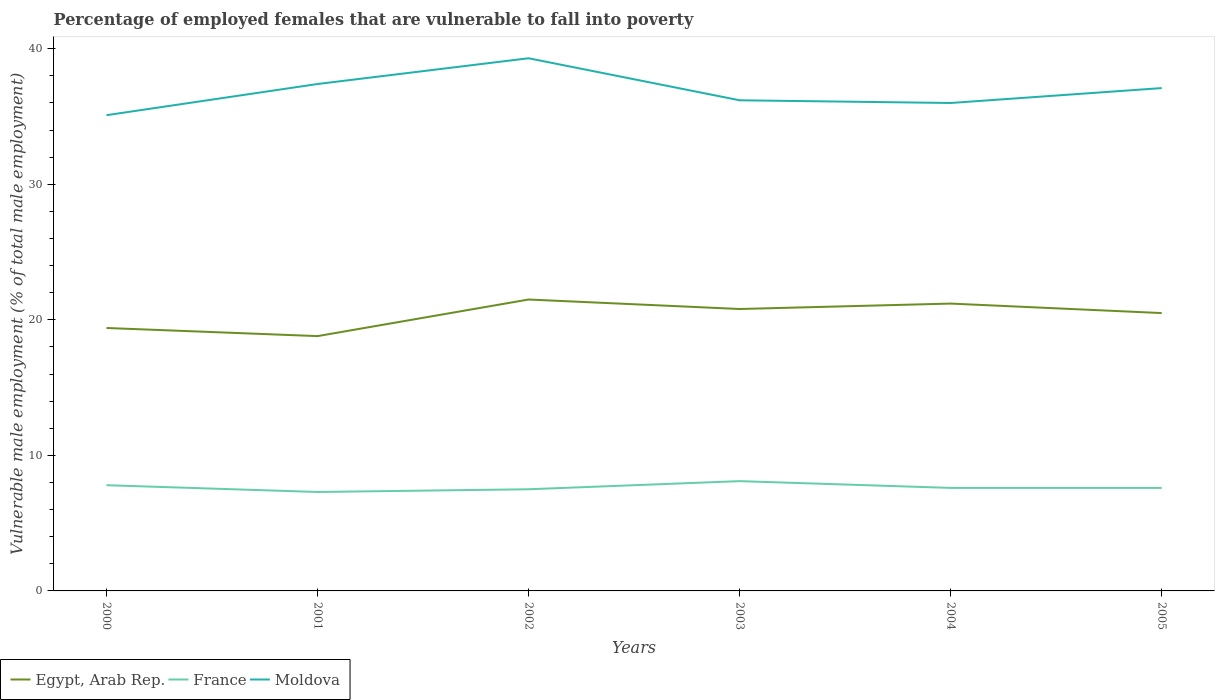Across all years, what is the maximum percentage of employed females who are vulnerable to fall into poverty in Egypt, Arab Rep.?
Keep it short and to the point. 18.8. In which year was the percentage of employed females who are vulnerable to fall into poverty in Egypt, Arab Rep. maximum?
Offer a terse response. 2001. What is the total percentage of employed females who are vulnerable to fall into poverty in France in the graph?
Your answer should be very brief. 0.5. What is the difference between the highest and the second highest percentage of employed females who are vulnerable to fall into poverty in Moldova?
Offer a very short reply. 4.2. How many years are there in the graph?
Provide a short and direct response. 6. What is the difference between two consecutive major ticks on the Y-axis?
Give a very brief answer. 10. Are the values on the major ticks of Y-axis written in scientific E-notation?
Give a very brief answer. No. Does the graph contain any zero values?
Offer a very short reply. No. Where does the legend appear in the graph?
Keep it short and to the point. Bottom left. How many legend labels are there?
Offer a very short reply. 3. What is the title of the graph?
Keep it short and to the point. Percentage of employed females that are vulnerable to fall into poverty. What is the label or title of the Y-axis?
Make the answer very short. Vulnerable male employment (% of total male employment). What is the Vulnerable male employment (% of total male employment) in Egypt, Arab Rep. in 2000?
Offer a terse response. 19.4. What is the Vulnerable male employment (% of total male employment) in France in 2000?
Offer a terse response. 7.8. What is the Vulnerable male employment (% of total male employment) of Moldova in 2000?
Keep it short and to the point. 35.1. What is the Vulnerable male employment (% of total male employment) of Egypt, Arab Rep. in 2001?
Ensure brevity in your answer.  18.8. What is the Vulnerable male employment (% of total male employment) in France in 2001?
Your response must be concise. 7.3. What is the Vulnerable male employment (% of total male employment) in Moldova in 2001?
Provide a short and direct response. 37.4. What is the Vulnerable male employment (% of total male employment) in Moldova in 2002?
Your answer should be compact. 39.3. What is the Vulnerable male employment (% of total male employment) of Egypt, Arab Rep. in 2003?
Your answer should be very brief. 20.8. What is the Vulnerable male employment (% of total male employment) of France in 2003?
Offer a terse response. 8.1. What is the Vulnerable male employment (% of total male employment) of Moldova in 2003?
Provide a short and direct response. 36.2. What is the Vulnerable male employment (% of total male employment) in Egypt, Arab Rep. in 2004?
Your answer should be very brief. 21.2. What is the Vulnerable male employment (% of total male employment) in France in 2004?
Your response must be concise. 7.6. What is the Vulnerable male employment (% of total male employment) of Moldova in 2004?
Provide a succinct answer. 36. What is the Vulnerable male employment (% of total male employment) of Egypt, Arab Rep. in 2005?
Give a very brief answer. 20.5. What is the Vulnerable male employment (% of total male employment) in France in 2005?
Provide a succinct answer. 7.6. What is the Vulnerable male employment (% of total male employment) of Moldova in 2005?
Your answer should be very brief. 37.1. Across all years, what is the maximum Vulnerable male employment (% of total male employment) of France?
Your answer should be very brief. 8.1. Across all years, what is the maximum Vulnerable male employment (% of total male employment) of Moldova?
Keep it short and to the point. 39.3. Across all years, what is the minimum Vulnerable male employment (% of total male employment) of Egypt, Arab Rep.?
Keep it short and to the point. 18.8. Across all years, what is the minimum Vulnerable male employment (% of total male employment) of France?
Offer a terse response. 7.3. Across all years, what is the minimum Vulnerable male employment (% of total male employment) in Moldova?
Provide a succinct answer. 35.1. What is the total Vulnerable male employment (% of total male employment) in Egypt, Arab Rep. in the graph?
Give a very brief answer. 122.2. What is the total Vulnerable male employment (% of total male employment) of France in the graph?
Offer a terse response. 45.9. What is the total Vulnerable male employment (% of total male employment) of Moldova in the graph?
Make the answer very short. 221.1. What is the difference between the Vulnerable male employment (% of total male employment) of Egypt, Arab Rep. in 2000 and that in 2001?
Your answer should be very brief. 0.6. What is the difference between the Vulnerable male employment (% of total male employment) in Moldova in 2000 and that in 2001?
Make the answer very short. -2.3. What is the difference between the Vulnerable male employment (% of total male employment) in France in 2000 and that in 2002?
Make the answer very short. 0.3. What is the difference between the Vulnerable male employment (% of total male employment) of Moldova in 2000 and that in 2002?
Provide a succinct answer. -4.2. What is the difference between the Vulnerable male employment (% of total male employment) in Egypt, Arab Rep. in 2000 and that in 2003?
Your response must be concise. -1.4. What is the difference between the Vulnerable male employment (% of total male employment) in France in 2000 and that in 2003?
Give a very brief answer. -0.3. What is the difference between the Vulnerable male employment (% of total male employment) in France in 2000 and that in 2004?
Your answer should be compact. 0.2. What is the difference between the Vulnerable male employment (% of total male employment) of Egypt, Arab Rep. in 2000 and that in 2005?
Provide a succinct answer. -1.1. What is the difference between the Vulnerable male employment (% of total male employment) of Moldova in 2000 and that in 2005?
Provide a succinct answer. -2. What is the difference between the Vulnerable male employment (% of total male employment) of Egypt, Arab Rep. in 2001 and that in 2002?
Make the answer very short. -2.7. What is the difference between the Vulnerable male employment (% of total male employment) of Egypt, Arab Rep. in 2001 and that in 2003?
Make the answer very short. -2. What is the difference between the Vulnerable male employment (% of total male employment) of Moldova in 2001 and that in 2003?
Offer a terse response. 1.2. What is the difference between the Vulnerable male employment (% of total male employment) in Egypt, Arab Rep. in 2001 and that in 2004?
Give a very brief answer. -2.4. What is the difference between the Vulnerable male employment (% of total male employment) of France in 2001 and that in 2004?
Ensure brevity in your answer.  -0.3. What is the difference between the Vulnerable male employment (% of total male employment) of Moldova in 2001 and that in 2004?
Make the answer very short. 1.4. What is the difference between the Vulnerable male employment (% of total male employment) in France in 2002 and that in 2003?
Make the answer very short. -0.6. What is the difference between the Vulnerable male employment (% of total male employment) of Moldova in 2002 and that in 2003?
Ensure brevity in your answer.  3.1. What is the difference between the Vulnerable male employment (% of total male employment) of Egypt, Arab Rep. in 2002 and that in 2004?
Provide a succinct answer. 0.3. What is the difference between the Vulnerable male employment (% of total male employment) in France in 2002 and that in 2004?
Your response must be concise. -0.1. What is the difference between the Vulnerable male employment (% of total male employment) in Egypt, Arab Rep. in 2002 and that in 2005?
Make the answer very short. 1. What is the difference between the Vulnerable male employment (% of total male employment) of France in 2002 and that in 2005?
Provide a short and direct response. -0.1. What is the difference between the Vulnerable male employment (% of total male employment) of Egypt, Arab Rep. in 2003 and that in 2004?
Give a very brief answer. -0.4. What is the difference between the Vulnerable male employment (% of total male employment) in Moldova in 2003 and that in 2004?
Provide a succinct answer. 0.2. What is the difference between the Vulnerable male employment (% of total male employment) of Egypt, Arab Rep. in 2003 and that in 2005?
Give a very brief answer. 0.3. What is the difference between the Vulnerable male employment (% of total male employment) in Moldova in 2003 and that in 2005?
Provide a short and direct response. -0.9. What is the difference between the Vulnerable male employment (% of total male employment) of Egypt, Arab Rep. in 2004 and that in 2005?
Your response must be concise. 0.7. What is the difference between the Vulnerable male employment (% of total male employment) in France in 2004 and that in 2005?
Keep it short and to the point. 0. What is the difference between the Vulnerable male employment (% of total male employment) in Moldova in 2004 and that in 2005?
Offer a very short reply. -1.1. What is the difference between the Vulnerable male employment (% of total male employment) of Egypt, Arab Rep. in 2000 and the Vulnerable male employment (% of total male employment) of Moldova in 2001?
Your answer should be compact. -18. What is the difference between the Vulnerable male employment (% of total male employment) in France in 2000 and the Vulnerable male employment (% of total male employment) in Moldova in 2001?
Provide a short and direct response. -29.6. What is the difference between the Vulnerable male employment (% of total male employment) of Egypt, Arab Rep. in 2000 and the Vulnerable male employment (% of total male employment) of France in 2002?
Keep it short and to the point. 11.9. What is the difference between the Vulnerable male employment (% of total male employment) in Egypt, Arab Rep. in 2000 and the Vulnerable male employment (% of total male employment) in Moldova in 2002?
Your response must be concise. -19.9. What is the difference between the Vulnerable male employment (% of total male employment) of France in 2000 and the Vulnerable male employment (% of total male employment) of Moldova in 2002?
Offer a very short reply. -31.5. What is the difference between the Vulnerable male employment (% of total male employment) of Egypt, Arab Rep. in 2000 and the Vulnerable male employment (% of total male employment) of France in 2003?
Your answer should be very brief. 11.3. What is the difference between the Vulnerable male employment (% of total male employment) of Egypt, Arab Rep. in 2000 and the Vulnerable male employment (% of total male employment) of Moldova in 2003?
Give a very brief answer. -16.8. What is the difference between the Vulnerable male employment (% of total male employment) of France in 2000 and the Vulnerable male employment (% of total male employment) of Moldova in 2003?
Your answer should be compact. -28.4. What is the difference between the Vulnerable male employment (% of total male employment) in Egypt, Arab Rep. in 2000 and the Vulnerable male employment (% of total male employment) in Moldova in 2004?
Keep it short and to the point. -16.6. What is the difference between the Vulnerable male employment (% of total male employment) in France in 2000 and the Vulnerable male employment (% of total male employment) in Moldova in 2004?
Your answer should be compact. -28.2. What is the difference between the Vulnerable male employment (% of total male employment) of Egypt, Arab Rep. in 2000 and the Vulnerable male employment (% of total male employment) of France in 2005?
Your answer should be compact. 11.8. What is the difference between the Vulnerable male employment (% of total male employment) in Egypt, Arab Rep. in 2000 and the Vulnerable male employment (% of total male employment) in Moldova in 2005?
Your answer should be compact. -17.7. What is the difference between the Vulnerable male employment (% of total male employment) in France in 2000 and the Vulnerable male employment (% of total male employment) in Moldova in 2005?
Provide a short and direct response. -29.3. What is the difference between the Vulnerable male employment (% of total male employment) of Egypt, Arab Rep. in 2001 and the Vulnerable male employment (% of total male employment) of France in 2002?
Your answer should be compact. 11.3. What is the difference between the Vulnerable male employment (% of total male employment) in Egypt, Arab Rep. in 2001 and the Vulnerable male employment (% of total male employment) in Moldova in 2002?
Your answer should be compact. -20.5. What is the difference between the Vulnerable male employment (% of total male employment) in France in 2001 and the Vulnerable male employment (% of total male employment) in Moldova in 2002?
Make the answer very short. -32. What is the difference between the Vulnerable male employment (% of total male employment) in Egypt, Arab Rep. in 2001 and the Vulnerable male employment (% of total male employment) in France in 2003?
Your response must be concise. 10.7. What is the difference between the Vulnerable male employment (% of total male employment) of Egypt, Arab Rep. in 2001 and the Vulnerable male employment (% of total male employment) of Moldova in 2003?
Offer a terse response. -17.4. What is the difference between the Vulnerable male employment (% of total male employment) of France in 2001 and the Vulnerable male employment (% of total male employment) of Moldova in 2003?
Make the answer very short. -28.9. What is the difference between the Vulnerable male employment (% of total male employment) in Egypt, Arab Rep. in 2001 and the Vulnerable male employment (% of total male employment) in Moldova in 2004?
Your response must be concise. -17.2. What is the difference between the Vulnerable male employment (% of total male employment) in France in 2001 and the Vulnerable male employment (% of total male employment) in Moldova in 2004?
Give a very brief answer. -28.7. What is the difference between the Vulnerable male employment (% of total male employment) of Egypt, Arab Rep. in 2001 and the Vulnerable male employment (% of total male employment) of France in 2005?
Offer a very short reply. 11.2. What is the difference between the Vulnerable male employment (% of total male employment) of Egypt, Arab Rep. in 2001 and the Vulnerable male employment (% of total male employment) of Moldova in 2005?
Offer a terse response. -18.3. What is the difference between the Vulnerable male employment (% of total male employment) in France in 2001 and the Vulnerable male employment (% of total male employment) in Moldova in 2005?
Ensure brevity in your answer.  -29.8. What is the difference between the Vulnerable male employment (% of total male employment) in Egypt, Arab Rep. in 2002 and the Vulnerable male employment (% of total male employment) in France in 2003?
Your response must be concise. 13.4. What is the difference between the Vulnerable male employment (% of total male employment) of Egypt, Arab Rep. in 2002 and the Vulnerable male employment (% of total male employment) of Moldova in 2003?
Ensure brevity in your answer.  -14.7. What is the difference between the Vulnerable male employment (% of total male employment) of France in 2002 and the Vulnerable male employment (% of total male employment) of Moldova in 2003?
Give a very brief answer. -28.7. What is the difference between the Vulnerable male employment (% of total male employment) of Egypt, Arab Rep. in 2002 and the Vulnerable male employment (% of total male employment) of France in 2004?
Offer a terse response. 13.9. What is the difference between the Vulnerable male employment (% of total male employment) of Egypt, Arab Rep. in 2002 and the Vulnerable male employment (% of total male employment) of Moldova in 2004?
Provide a short and direct response. -14.5. What is the difference between the Vulnerable male employment (% of total male employment) of France in 2002 and the Vulnerable male employment (% of total male employment) of Moldova in 2004?
Provide a short and direct response. -28.5. What is the difference between the Vulnerable male employment (% of total male employment) of Egypt, Arab Rep. in 2002 and the Vulnerable male employment (% of total male employment) of France in 2005?
Offer a very short reply. 13.9. What is the difference between the Vulnerable male employment (% of total male employment) in Egypt, Arab Rep. in 2002 and the Vulnerable male employment (% of total male employment) in Moldova in 2005?
Provide a short and direct response. -15.6. What is the difference between the Vulnerable male employment (% of total male employment) in France in 2002 and the Vulnerable male employment (% of total male employment) in Moldova in 2005?
Keep it short and to the point. -29.6. What is the difference between the Vulnerable male employment (% of total male employment) of Egypt, Arab Rep. in 2003 and the Vulnerable male employment (% of total male employment) of Moldova in 2004?
Provide a short and direct response. -15.2. What is the difference between the Vulnerable male employment (% of total male employment) in France in 2003 and the Vulnerable male employment (% of total male employment) in Moldova in 2004?
Provide a short and direct response. -27.9. What is the difference between the Vulnerable male employment (% of total male employment) in Egypt, Arab Rep. in 2003 and the Vulnerable male employment (% of total male employment) in Moldova in 2005?
Ensure brevity in your answer.  -16.3. What is the difference between the Vulnerable male employment (% of total male employment) of Egypt, Arab Rep. in 2004 and the Vulnerable male employment (% of total male employment) of Moldova in 2005?
Make the answer very short. -15.9. What is the difference between the Vulnerable male employment (% of total male employment) in France in 2004 and the Vulnerable male employment (% of total male employment) in Moldova in 2005?
Offer a terse response. -29.5. What is the average Vulnerable male employment (% of total male employment) in Egypt, Arab Rep. per year?
Make the answer very short. 20.37. What is the average Vulnerable male employment (% of total male employment) of France per year?
Ensure brevity in your answer.  7.65. What is the average Vulnerable male employment (% of total male employment) of Moldova per year?
Offer a very short reply. 36.85. In the year 2000, what is the difference between the Vulnerable male employment (% of total male employment) in Egypt, Arab Rep. and Vulnerable male employment (% of total male employment) in France?
Make the answer very short. 11.6. In the year 2000, what is the difference between the Vulnerable male employment (% of total male employment) of Egypt, Arab Rep. and Vulnerable male employment (% of total male employment) of Moldova?
Keep it short and to the point. -15.7. In the year 2000, what is the difference between the Vulnerable male employment (% of total male employment) in France and Vulnerable male employment (% of total male employment) in Moldova?
Provide a short and direct response. -27.3. In the year 2001, what is the difference between the Vulnerable male employment (% of total male employment) in Egypt, Arab Rep. and Vulnerable male employment (% of total male employment) in France?
Provide a succinct answer. 11.5. In the year 2001, what is the difference between the Vulnerable male employment (% of total male employment) in Egypt, Arab Rep. and Vulnerable male employment (% of total male employment) in Moldova?
Ensure brevity in your answer.  -18.6. In the year 2001, what is the difference between the Vulnerable male employment (% of total male employment) of France and Vulnerable male employment (% of total male employment) of Moldova?
Provide a short and direct response. -30.1. In the year 2002, what is the difference between the Vulnerable male employment (% of total male employment) of Egypt, Arab Rep. and Vulnerable male employment (% of total male employment) of France?
Give a very brief answer. 14. In the year 2002, what is the difference between the Vulnerable male employment (% of total male employment) in Egypt, Arab Rep. and Vulnerable male employment (% of total male employment) in Moldova?
Keep it short and to the point. -17.8. In the year 2002, what is the difference between the Vulnerable male employment (% of total male employment) in France and Vulnerable male employment (% of total male employment) in Moldova?
Ensure brevity in your answer.  -31.8. In the year 2003, what is the difference between the Vulnerable male employment (% of total male employment) in Egypt, Arab Rep. and Vulnerable male employment (% of total male employment) in France?
Your answer should be very brief. 12.7. In the year 2003, what is the difference between the Vulnerable male employment (% of total male employment) in Egypt, Arab Rep. and Vulnerable male employment (% of total male employment) in Moldova?
Offer a terse response. -15.4. In the year 2003, what is the difference between the Vulnerable male employment (% of total male employment) in France and Vulnerable male employment (% of total male employment) in Moldova?
Your answer should be compact. -28.1. In the year 2004, what is the difference between the Vulnerable male employment (% of total male employment) of Egypt, Arab Rep. and Vulnerable male employment (% of total male employment) of Moldova?
Ensure brevity in your answer.  -14.8. In the year 2004, what is the difference between the Vulnerable male employment (% of total male employment) in France and Vulnerable male employment (% of total male employment) in Moldova?
Make the answer very short. -28.4. In the year 2005, what is the difference between the Vulnerable male employment (% of total male employment) of Egypt, Arab Rep. and Vulnerable male employment (% of total male employment) of France?
Provide a short and direct response. 12.9. In the year 2005, what is the difference between the Vulnerable male employment (% of total male employment) in Egypt, Arab Rep. and Vulnerable male employment (% of total male employment) in Moldova?
Give a very brief answer. -16.6. In the year 2005, what is the difference between the Vulnerable male employment (% of total male employment) of France and Vulnerable male employment (% of total male employment) of Moldova?
Offer a very short reply. -29.5. What is the ratio of the Vulnerable male employment (% of total male employment) in Egypt, Arab Rep. in 2000 to that in 2001?
Your response must be concise. 1.03. What is the ratio of the Vulnerable male employment (% of total male employment) of France in 2000 to that in 2001?
Provide a succinct answer. 1.07. What is the ratio of the Vulnerable male employment (% of total male employment) in Moldova in 2000 to that in 2001?
Make the answer very short. 0.94. What is the ratio of the Vulnerable male employment (% of total male employment) in Egypt, Arab Rep. in 2000 to that in 2002?
Provide a short and direct response. 0.9. What is the ratio of the Vulnerable male employment (% of total male employment) in Moldova in 2000 to that in 2002?
Ensure brevity in your answer.  0.89. What is the ratio of the Vulnerable male employment (% of total male employment) in Egypt, Arab Rep. in 2000 to that in 2003?
Ensure brevity in your answer.  0.93. What is the ratio of the Vulnerable male employment (% of total male employment) of France in 2000 to that in 2003?
Give a very brief answer. 0.96. What is the ratio of the Vulnerable male employment (% of total male employment) of Moldova in 2000 to that in 2003?
Provide a succinct answer. 0.97. What is the ratio of the Vulnerable male employment (% of total male employment) of Egypt, Arab Rep. in 2000 to that in 2004?
Keep it short and to the point. 0.92. What is the ratio of the Vulnerable male employment (% of total male employment) of France in 2000 to that in 2004?
Offer a very short reply. 1.03. What is the ratio of the Vulnerable male employment (% of total male employment) of Egypt, Arab Rep. in 2000 to that in 2005?
Offer a terse response. 0.95. What is the ratio of the Vulnerable male employment (% of total male employment) in France in 2000 to that in 2005?
Your answer should be compact. 1.03. What is the ratio of the Vulnerable male employment (% of total male employment) in Moldova in 2000 to that in 2005?
Provide a short and direct response. 0.95. What is the ratio of the Vulnerable male employment (% of total male employment) of Egypt, Arab Rep. in 2001 to that in 2002?
Provide a succinct answer. 0.87. What is the ratio of the Vulnerable male employment (% of total male employment) in France in 2001 to that in 2002?
Your response must be concise. 0.97. What is the ratio of the Vulnerable male employment (% of total male employment) of Moldova in 2001 to that in 2002?
Offer a terse response. 0.95. What is the ratio of the Vulnerable male employment (% of total male employment) in Egypt, Arab Rep. in 2001 to that in 2003?
Ensure brevity in your answer.  0.9. What is the ratio of the Vulnerable male employment (% of total male employment) in France in 2001 to that in 2003?
Your answer should be compact. 0.9. What is the ratio of the Vulnerable male employment (% of total male employment) of Moldova in 2001 to that in 2003?
Your response must be concise. 1.03. What is the ratio of the Vulnerable male employment (% of total male employment) in Egypt, Arab Rep. in 2001 to that in 2004?
Your answer should be very brief. 0.89. What is the ratio of the Vulnerable male employment (% of total male employment) in France in 2001 to that in 2004?
Provide a succinct answer. 0.96. What is the ratio of the Vulnerable male employment (% of total male employment) in Moldova in 2001 to that in 2004?
Give a very brief answer. 1.04. What is the ratio of the Vulnerable male employment (% of total male employment) in Egypt, Arab Rep. in 2001 to that in 2005?
Your response must be concise. 0.92. What is the ratio of the Vulnerable male employment (% of total male employment) of France in 2001 to that in 2005?
Offer a very short reply. 0.96. What is the ratio of the Vulnerable male employment (% of total male employment) in Moldova in 2001 to that in 2005?
Your response must be concise. 1.01. What is the ratio of the Vulnerable male employment (% of total male employment) in Egypt, Arab Rep. in 2002 to that in 2003?
Ensure brevity in your answer.  1.03. What is the ratio of the Vulnerable male employment (% of total male employment) of France in 2002 to that in 2003?
Your response must be concise. 0.93. What is the ratio of the Vulnerable male employment (% of total male employment) in Moldova in 2002 to that in 2003?
Your response must be concise. 1.09. What is the ratio of the Vulnerable male employment (% of total male employment) in Egypt, Arab Rep. in 2002 to that in 2004?
Your response must be concise. 1.01. What is the ratio of the Vulnerable male employment (% of total male employment) of France in 2002 to that in 2004?
Give a very brief answer. 0.99. What is the ratio of the Vulnerable male employment (% of total male employment) in Moldova in 2002 to that in 2004?
Provide a succinct answer. 1.09. What is the ratio of the Vulnerable male employment (% of total male employment) of Egypt, Arab Rep. in 2002 to that in 2005?
Provide a short and direct response. 1.05. What is the ratio of the Vulnerable male employment (% of total male employment) in France in 2002 to that in 2005?
Your answer should be very brief. 0.99. What is the ratio of the Vulnerable male employment (% of total male employment) in Moldova in 2002 to that in 2005?
Make the answer very short. 1.06. What is the ratio of the Vulnerable male employment (% of total male employment) of Egypt, Arab Rep. in 2003 to that in 2004?
Provide a succinct answer. 0.98. What is the ratio of the Vulnerable male employment (% of total male employment) in France in 2003 to that in 2004?
Ensure brevity in your answer.  1.07. What is the ratio of the Vulnerable male employment (% of total male employment) of Moldova in 2003 to that in 2004?
Provide a succinct answer. 1.01. What is the ratio of the Vulnerable male employment (% of total male employment) of Egypt, Arab Rep. in 2003 to that in 2005?
Your answer should be compact. 1.01. What is the ratio of the Vulnerable male employment (% of total male employment) of France in 2003 to that in 2005?
Your answer should be very brief. 1.07. What is the ratio of the Vulnerable male employment (% of total male employment) in Moldova in 2003 to that in 2005?
Provide a short and direct response. 0.98. What is the ratio of the Vulnerable male employment (% of total male employment) of Egypt, Arab Rep. in 2004 to that in 2005?
Your answer should be very brief. 1.03. What is the ratio of the Vulnerable male employment (% of total male employment) of France in 2004 to that in 2005?
Provide a short and direct response. 1. What is the ratio of the Vulnerable male employment (% of total male employment) of Moldova in 2004 to that in 2005?
Your answer should be very brief. 0.97. What is the difference between the highest and the second highest Vulnerable male employment (% of total male employment) in Moldova?
Provide a succinct answer. 1.9. 